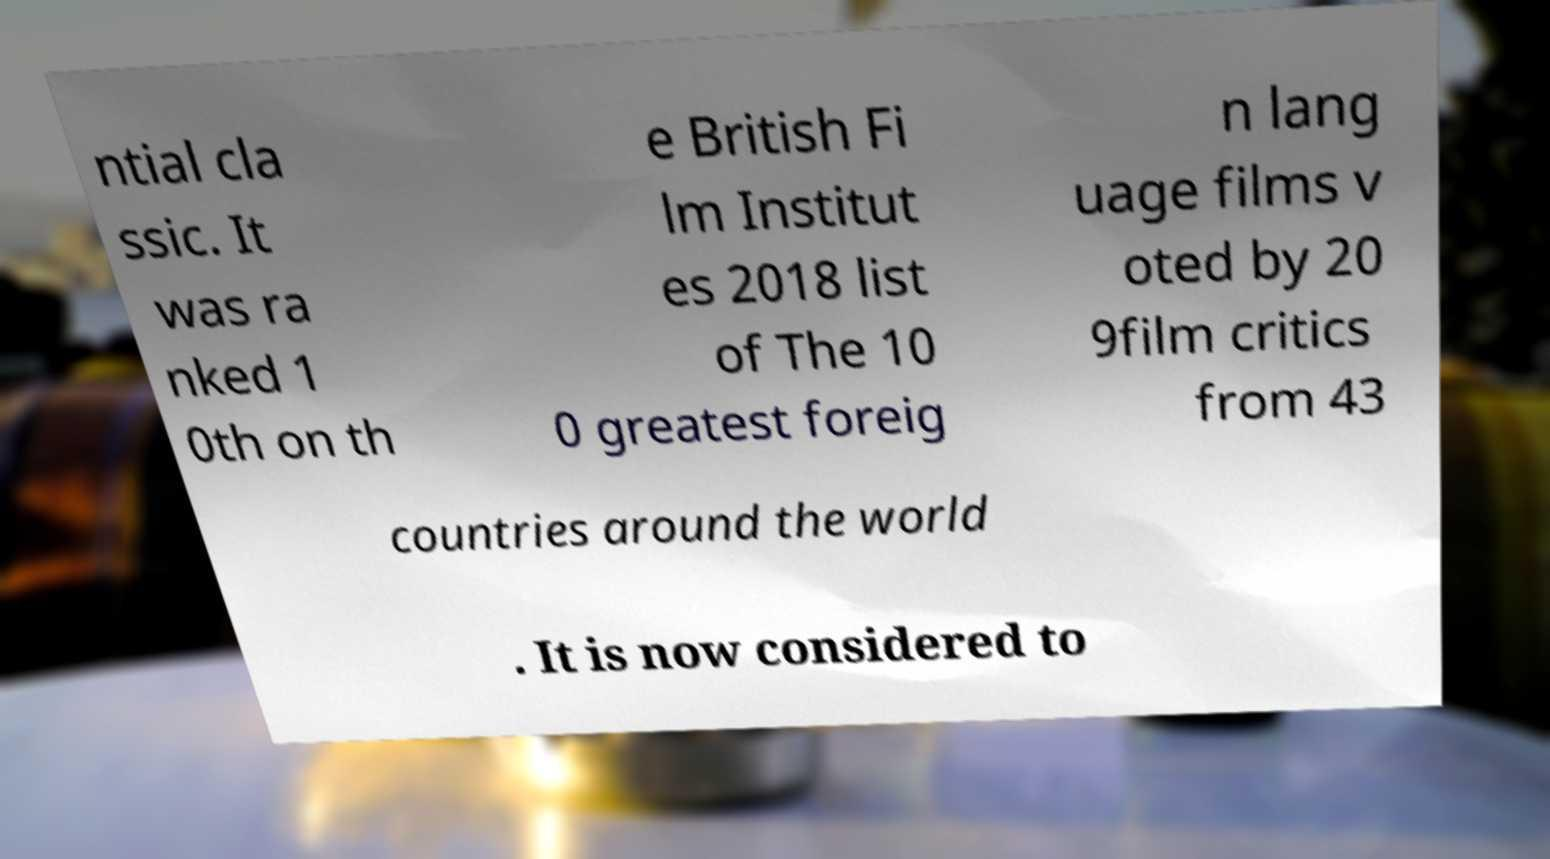What messages or text are displayed in this image? I need them in a readable, typed format. ntial cla ssic. It was ra nked 1 0th on th e British Fi lm Institut es 2018 list of The 10 0 greatest foreig n lang uage films v oted by 20 9film critics from 43 countries around the world . It is now considered to 